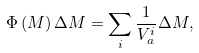Convert formula to latex. <formula><loc_0><loc_0><loc_500><loc_500>\Phi \left ( M \right ) \Delta M = \sum _ { i } \frac { 1 } { V _ { a } ^ { i } } \Delta M ,</formula> 